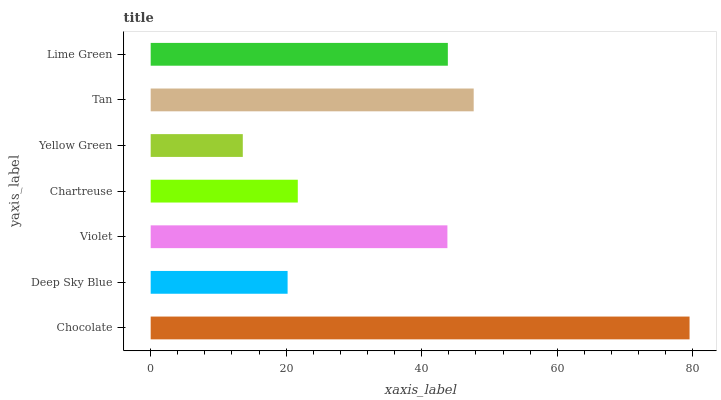Is Yellow Green the minimum?
Answer yes or no. Yes. Is Chocolate the maximum?
Answer yes or no. Yes. Is Deep Sky Blue the minimum?
Answer yes or no. No. Is Deep Sky Blue the maximum?
Answer yes or no. No. Is Chocolate greater than Deep Sky Blue?
Answer yes or no. Yes. Is Deep Sky Blue less than Chocolate?
Answer yes or no. Yes. Is Deep Sky Blue greater than Chocolate?
Answer yes or no. No. Is Chocolate less than Deep Sky Blue?
Answer yes or no. No. Is Violet the high median?
Answer yes or no. Yes. Is Violet the low median?
Answer yes or no. Yes. Is Lime Green the high median?
Answer yes or no. No. Is Chartreuse the low median?
Answer yes or no. No. 